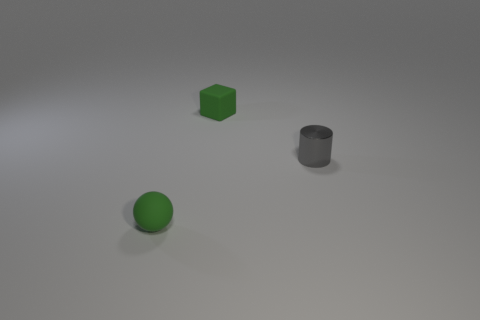There is a green object that is behind the gray metallic cylinder; does it have the same shape as the metallic thing?
Offer a very short reply. No. Does the rubber ball have the same color as the tiny matte block?
Your answer should be compact. Yes. How many things are either tiny green objects that are behind the green rubber sphere or gray metal objects?
Keep it short and to the point. 2. What shape is the gray object that is the same size as the rubber block?
Offer a very short reply. Cylinder. Do the green cube that is right of the matte sphere and the object in front of the small shiny cylinder have the same size?
Keep it short and to the point. Yes. The tiny sphere that is made of the same material as the green cube is what color?
Your response must be concise. Green. Does the tiny green thing behind the cylinder have the same material as the object that is to the right of the small rubber cube?
Your response must be concise. No. Is there a matte thing of the same size as the matte block?
Provide a succinct answer. Yes. What number of rubber objects have the same color as the metallic cylinder?
Your answer should be very brief. 0. The green matte thing that is to the left of the matte object behind the metal object is what shape?
Make the answer very short. Sphere. 